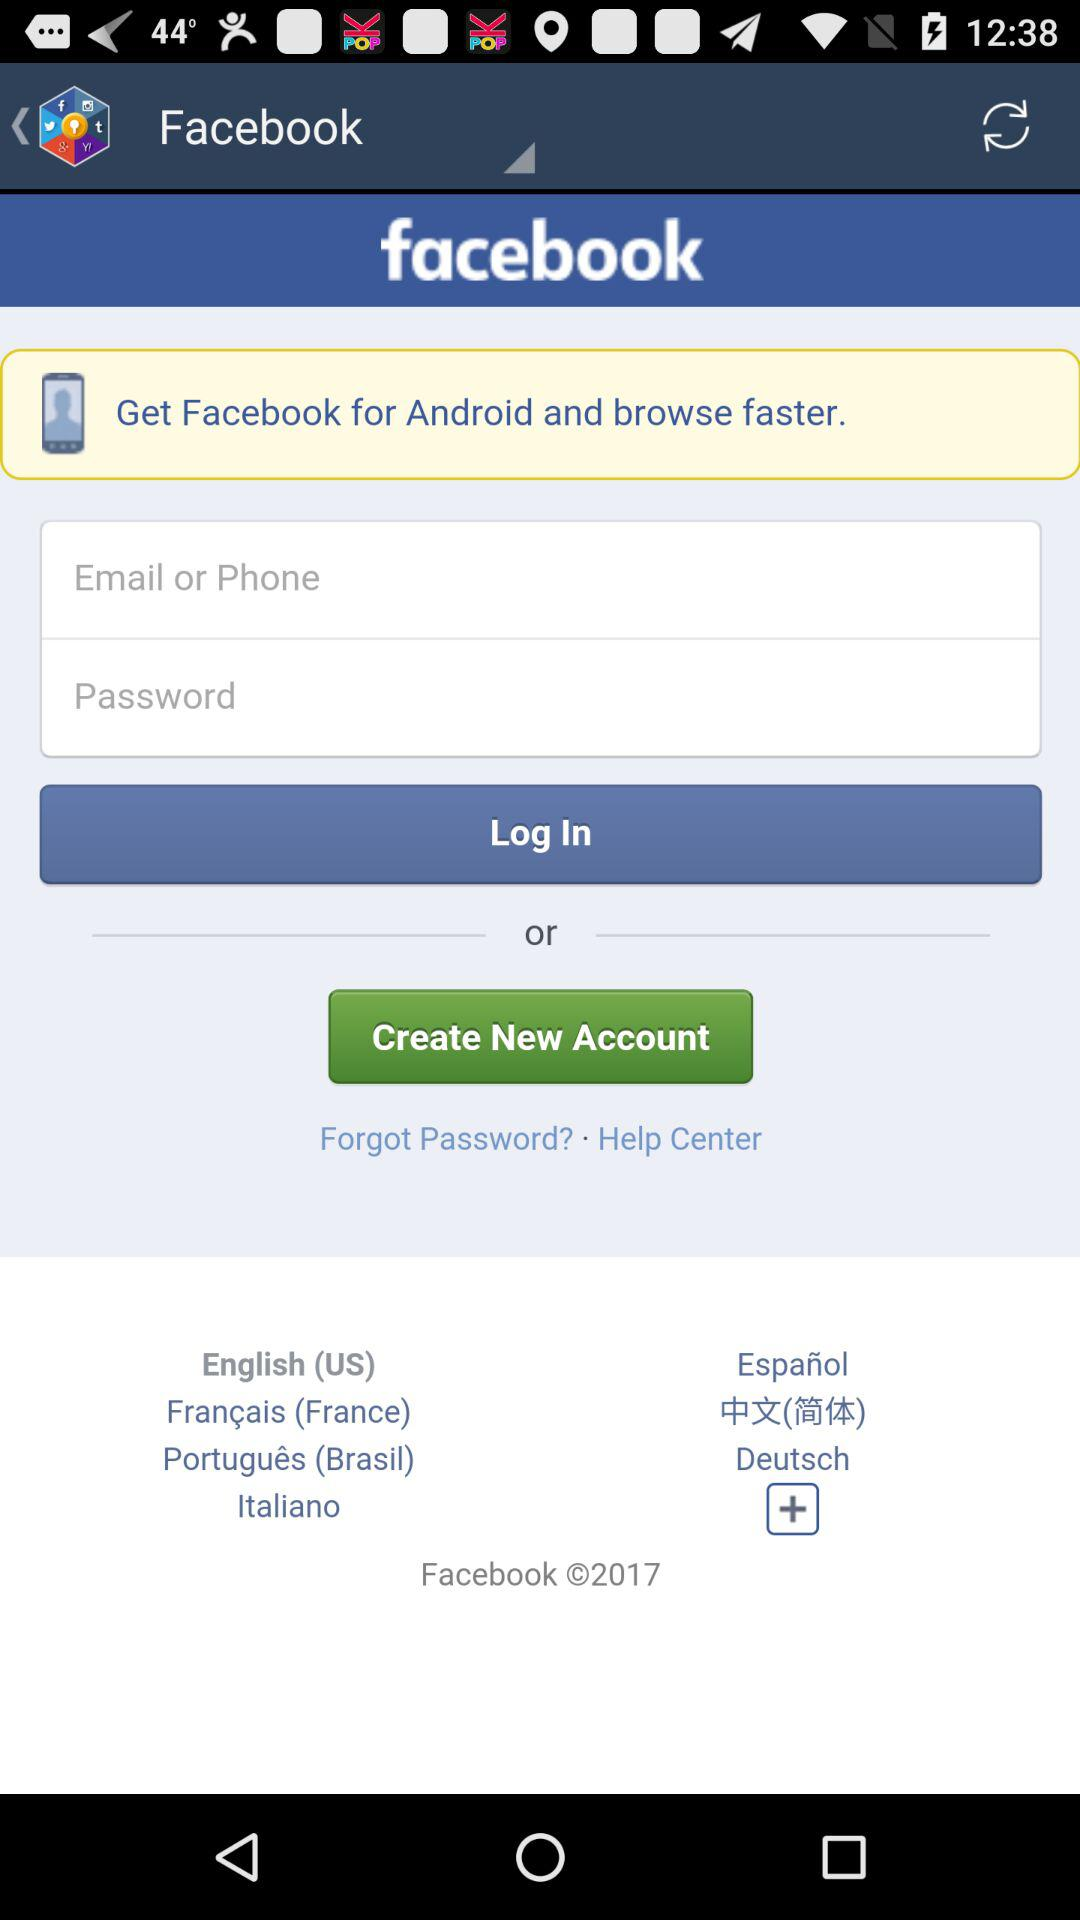What is the app name? The app name is "Facebook". 